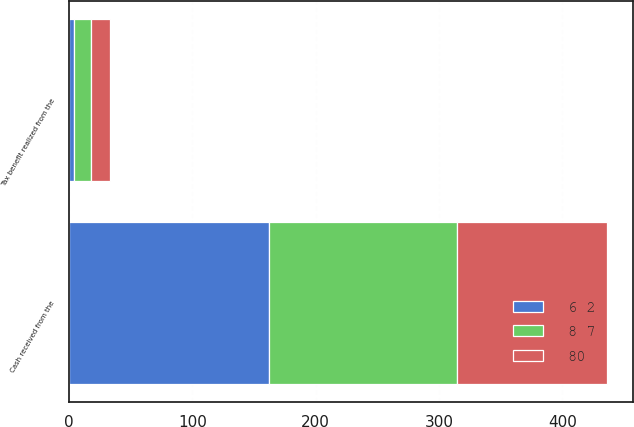Convert chart. <chart><loc_0><loc_0><loc_500><loc_500><stacked_bar_chart><ecel><fcel>Cash received from the<fcel>Tax benefit realized from the<nl><fcel>8 7<fcel>153<fcel>14<nl><fcel>6 2<fcel>162<fcel>4<nl><fcel>80<fcel>121<fcel>15<nl></chart> 